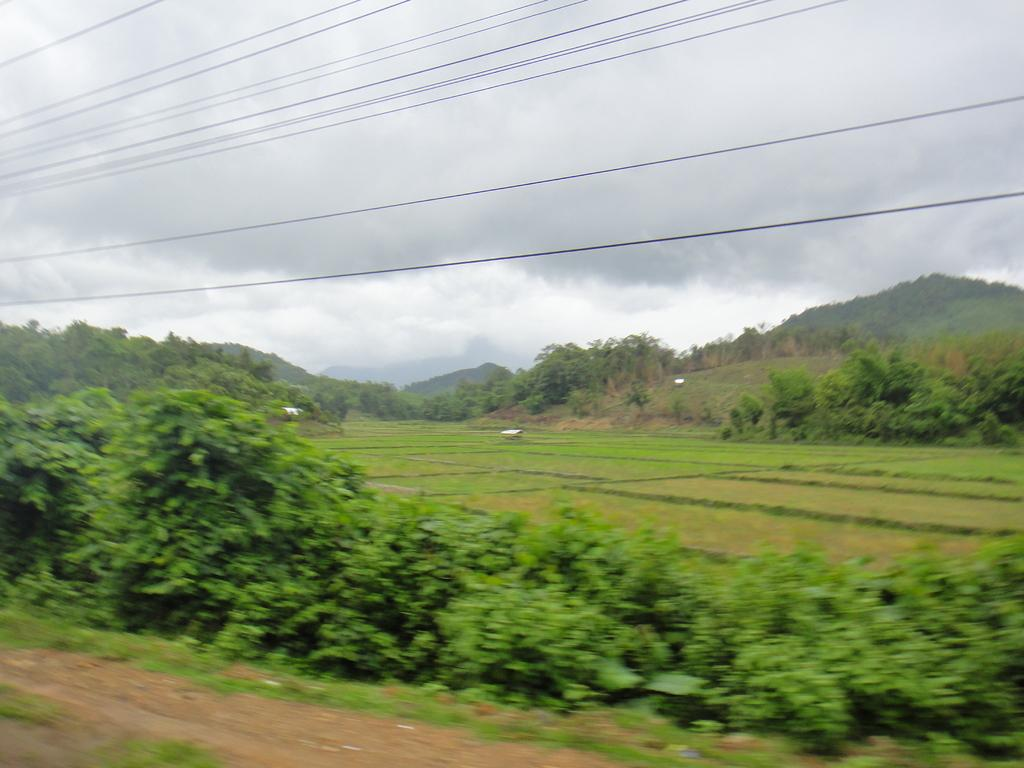What type of vegetation can be seen in the image? There are trees in the image. What else can be seen in the image besides trees? There are cables visible in the image. What is visible in the background of the image? The sky is visible in the image. How much income do the sisters in the image earn? There are no sisters present in the image, so it is not possible to determine their income. 